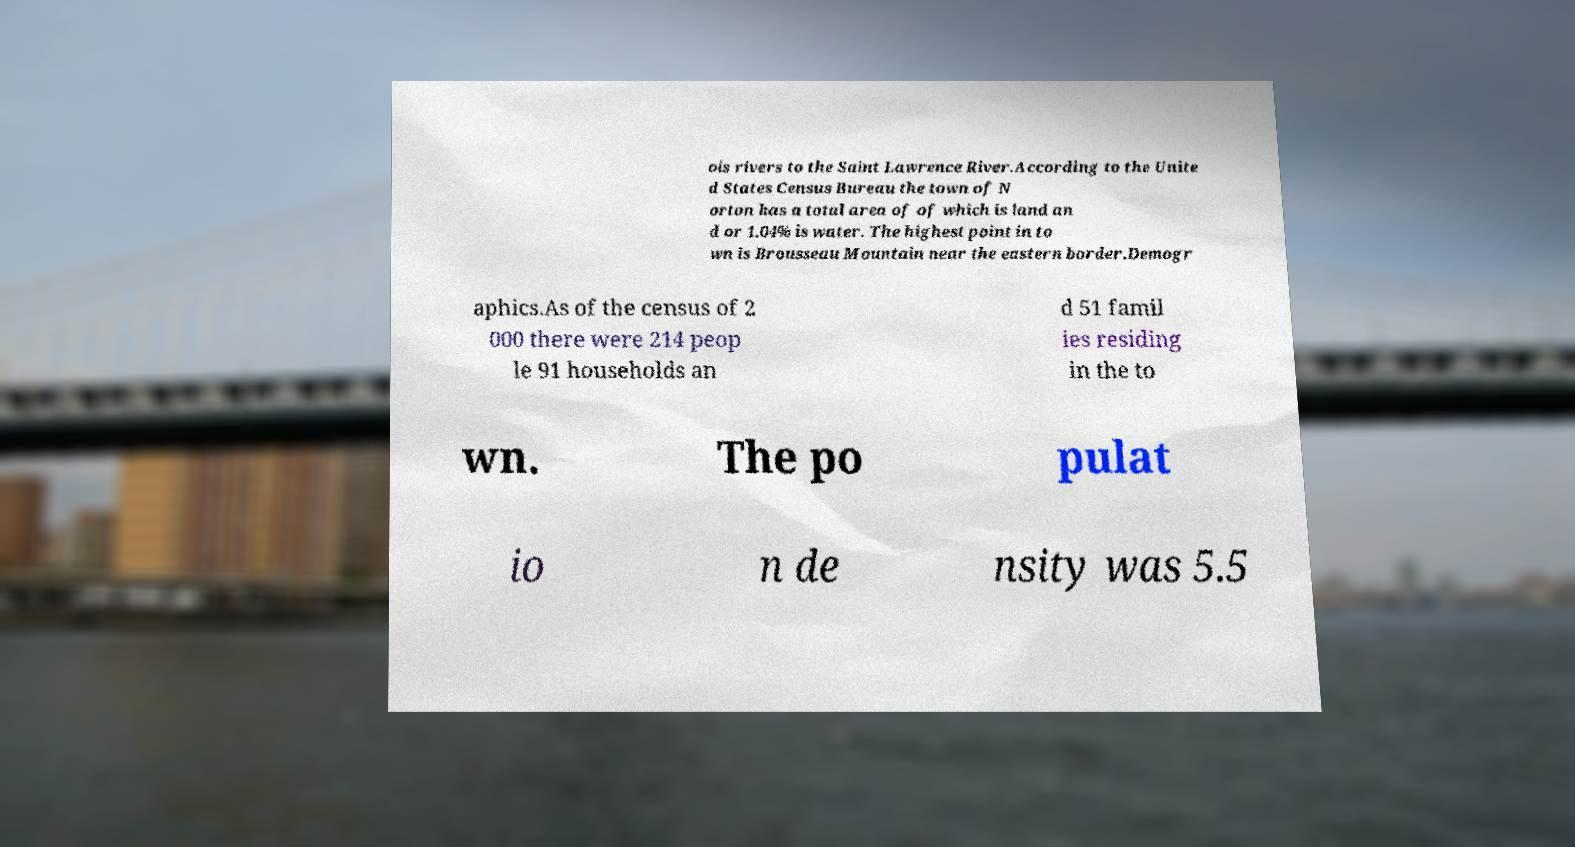Could you assist in decoding the text presented in this image and type it out clearly? ois rivers to the Saint Lawrence River.According to the Unite d States Census Bureau the town of N orton has a total area of of which is land an d or 1.04% is water. The highest point in to wn is Brousseau Mountain near the eastern border.Demogr aphics.As of the census of 2 000 there were 214 peop le 91 households an d 51 famil ies residing in the to wn. The po pulat io n de nsity was 5.5 